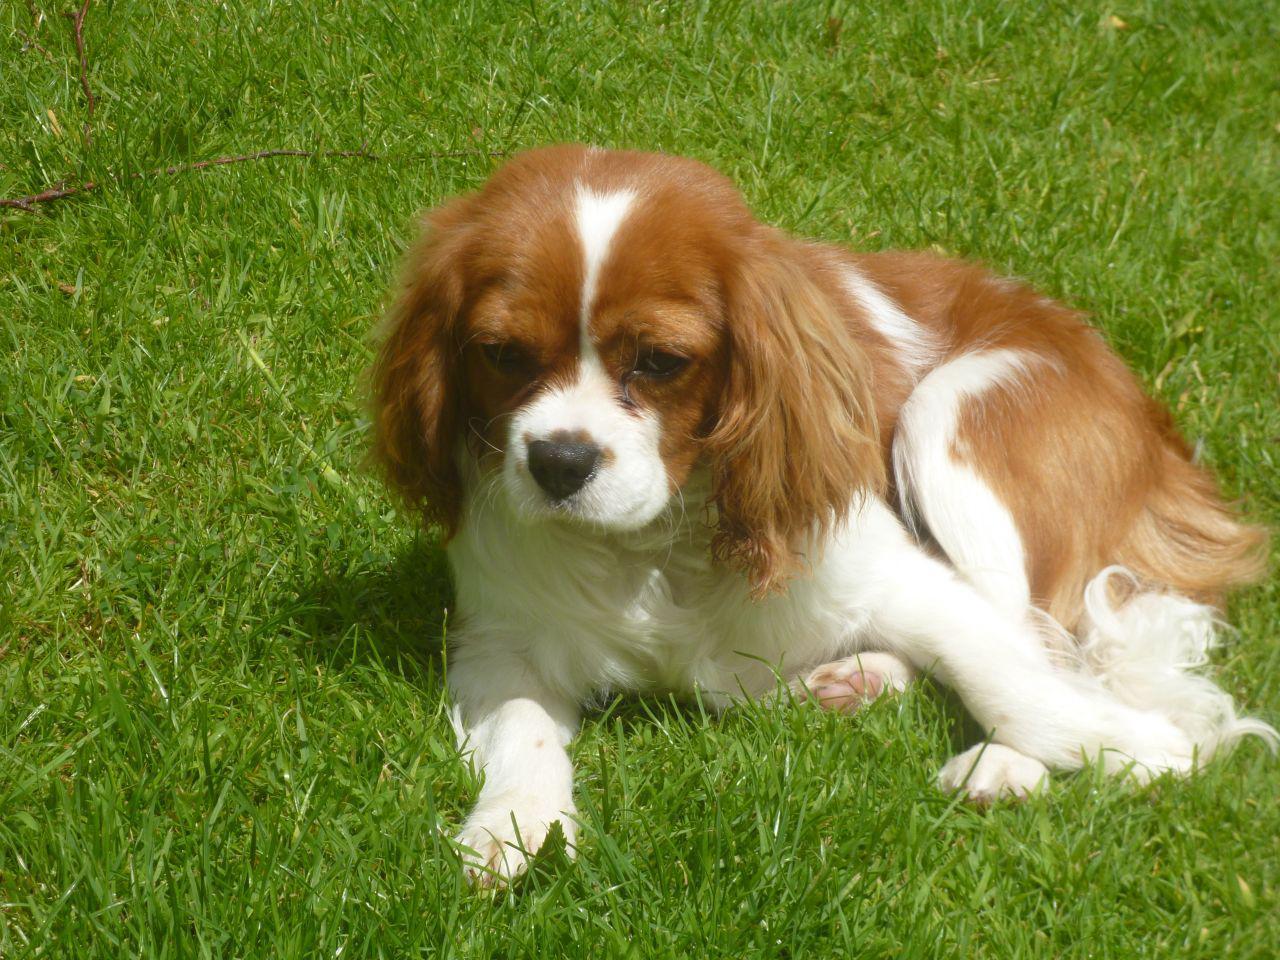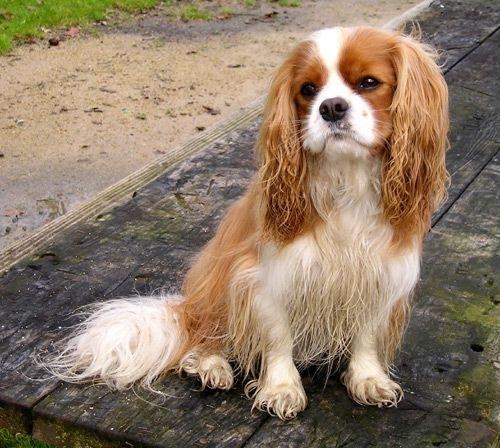The first image is the image on the left, the second image is the image on the right. For the images shown, is this caption "An image shows just one dog on green grass." true? Answer yes or no. Yes. The first image is the image on the left, the second image is the image on the right. Analyze the images presented: Is the assertion "An image shows one spaniel posed on green grass." valid? Answer yes or no. Yes. The first image is the image on the left, the second image is the image on the right. Analyze the images presented: Is the assertion "One of the images shows one dog on grass." valid? Answer yes or no. Yes. The first image is the image on the left, the second image is the image on the right. Assess this claim about the two images: "There is a single dog on grass in one of the images.". Correct or not? Answer yes or no. Yes. 